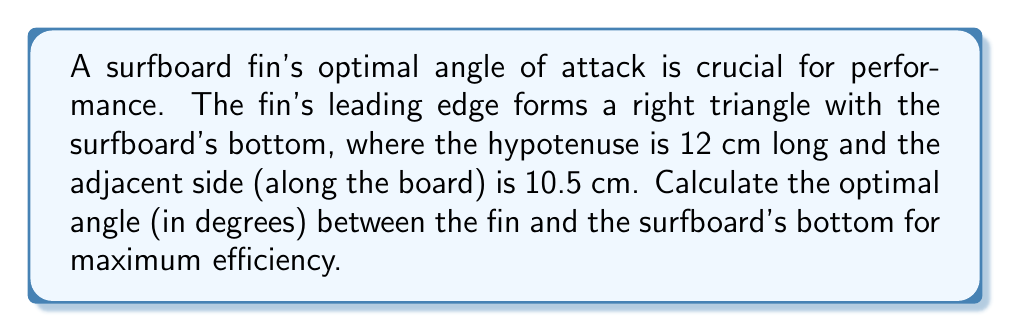Give your solution to this math problem. To solve this problem, we'll use trigonometry, specifically the cosine function in a right triangle.

1. Identify the given information:
   - The hypotenuse (c) = 12 cm
   - The adjacent side (a) = 10.5 cm
   - We need to find the angle (θ) between the fin and the surfboard's bottom

2. Recall the cosine function in a right triangle:
   $$ \cos(\theta) = \frac{\text{adjacent}}{\text{hypotenuse}} $$

3. Substitute the known values:
   $$ \cos(\theta) = \frac{10.5}{12} $$

4. To find θ, we need to use the inverse cosine (arccos) function:
   $$ \theta = \arccos(\frac{10.5}{12}) $$

5. Calculate the result:
   $$ \theta \approx 28.95^\circ $$

6. Round to the nearest tenth of a degree:
   $$ \theta \approx 29.0^\circ $$

[asy]
import geometry;

size(200);
pair A=(0,0), B=(10.5,0), C=(10.5,5.83);
draw(A--B--C--A);
draw(rightanglemark(A,B,C,20));
label("12 cm",A--C,W);
label("10.5 cm",A--B,S);
label("$\theta$",B,NE);
[/asy]
Answer: $29.0^\circ$ 